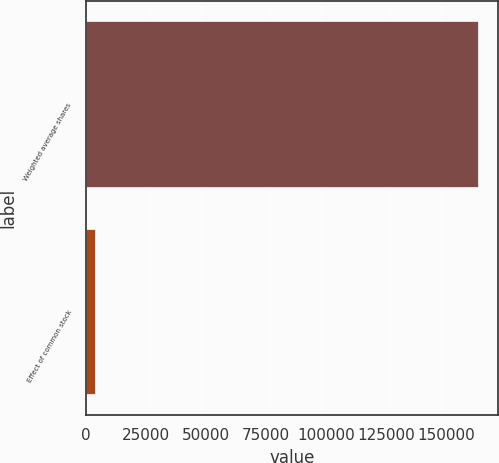Convert chart. <chart><loc_0><loc_0><loc_500><loc_500><bar_chart><fcel>Weighted average shares<fcel>Effect of common stock<nl><fcel>163439<fcel>3736<nl></chart> 